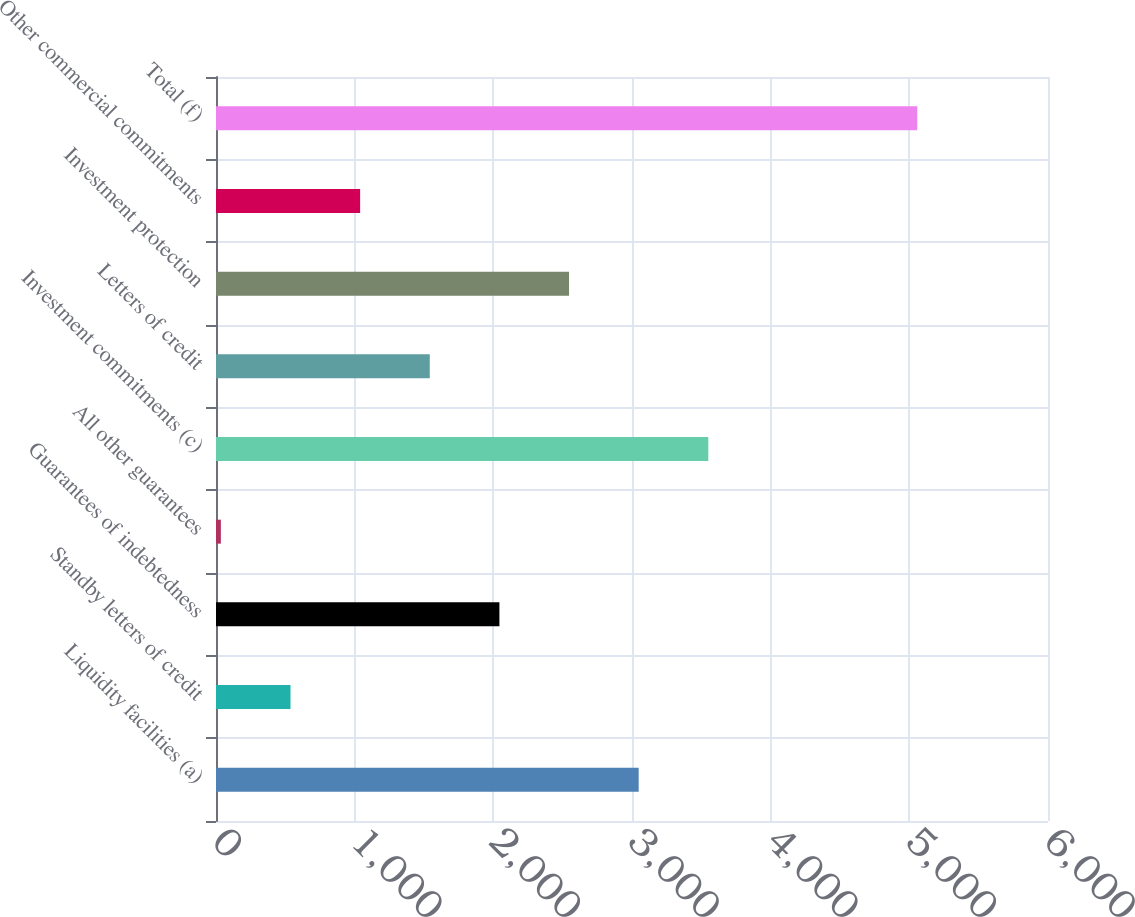Convert chart to OTSL. <chart><loc_0><loc_0><loc_500><loc_500><bar_chart><fcel>Liquidity facilities (a)<fcel>Standby letters of credit<fcel>Guarantees of indebtedness<fcel>All other guarantees<fcel>Investment commitments (c)<fcel>Letters of credit<fcel>Investment protection<fcel>Other commercial commitments<fcel>Total (f)<nl><fcel>3048.2<fcel>537.2<fcel>2043.8<fcel>35<fcel>3550.4<fcel>1541.6<fcel>2546<fcel>1039.4<fcel>5057<nl></chart> 